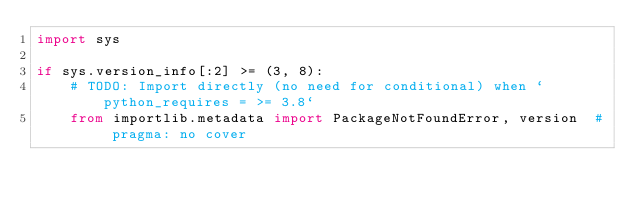<code> <loc_0><loc_0><loc_500><loc_500><_Python_>import sys

if sys.version_info[:2] >= (3, 8):
    # TODO: Import directly (no need for conditional) when `python_requires = >= 3.8`
    from importlib.metadata import PackageNotFoundError, version  # pragma: no cover</code> 